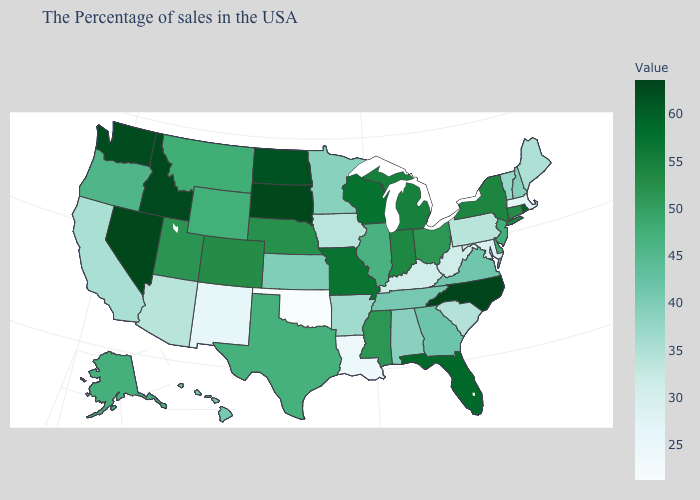Is the legend a continuous bar?
Quick response, please. Yes. Which states have the highest value in the USA?
Write a very short answer. North Carolina. Which states hav the highest value in the South?
Short answer required. North Carolina. Does South Dakota have the highest value in the MidWest?
Concise answer only. Yes. Among the states that border Idaho , does Montana have the highest value?
Be succinct. No. 